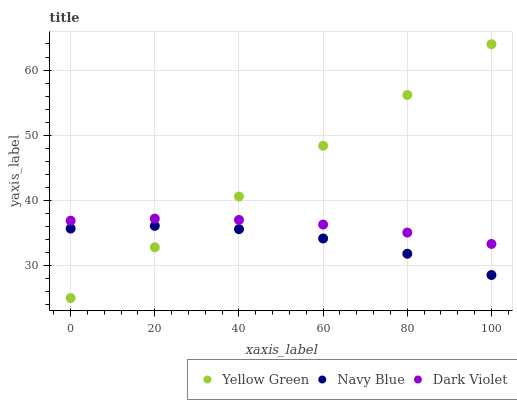Does Navy Blue have the minimum area under the curve?
Answer yes or no. Yes. Does Yellow Green have the maximum area under the curve?
Answer yes or no. Yes. Does Dark Violet have the minimum area under the curve?
Answer yes or no. No. Does Dark Violet have the maximum area under the curve?
Answer yes or no. No. Is Yellow Green the smoothest?
Answer yes or no. Yes. Is Navy Blue the roughest?
Answer yes or no. Yes. Is Dark Violet the smoothest?
Answer yes or no. No. Is Dark Violet the roughest?
Answer yes or no. No. Does Yellow Green have the lowest value?
Answer yes or no. Yes. Does Dark Violet have the lowest value?
Answer yes or no. No. Does Yellow Green have the highest value?
Answer yes or no. Yes. Does Dark Violet have the highest value?
Answer yes or no. No. Is Navy Blue less than Dark Violet?
Answer yes or no. Yes. Is Dark Violet greater than Navy Blue?
Answer yes or no. Yes. Does Yellow Green intersect Dark Violet?
Answer yes or no. Yes. Is Yellow Green less than Dark Violet?
Answer yes or no. No. Is Yellow Green greater than Dark Violet?
Answer yes or no. No. Does Navy Blue intersect Dark Violet?
Answer yes or no. No. 